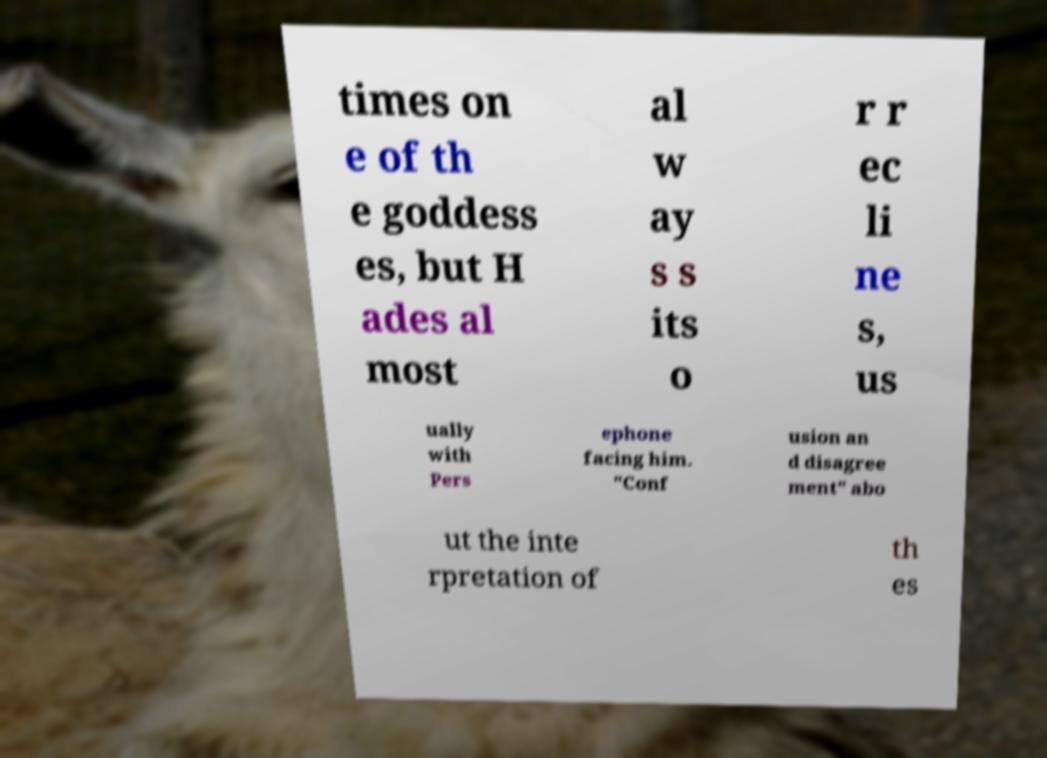Can you read and provide the text displayed in the image?This photo seems to have some interesting text. Can you extract and type it out for me? times on e of th e goddess es, but H ades al most al w ay s s its o r r ec li ne s, us ually with Pers ephone facing him. "Conf usion an d disagree ment" abo ut the inte rpretation of th es 